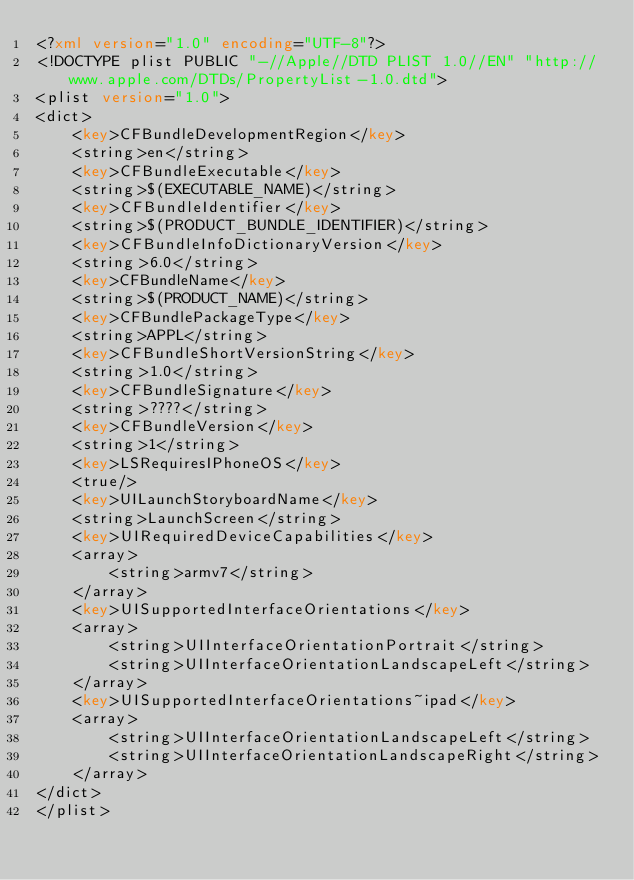<code> <loc_0><loc_0><loc_500><loc_500><_XML_><?xml version="1.0" encoding="UTF-8"?>
<!DOCTYPE plist PUBLIC "-//Apple//DTD PLIST 1.0//EN" "http://www.apple.com/DTDs/PropertyList-1.0.dtd">
<plist version="1.0">
<dict>
	<key>CFBundleDevelopmentRegion</key>
	<string>en</string>
	<key>CFBundleExecutable</key>
	<string>$(EXECUTABLE_NAME)</string>
	<key>CFBundleIdentifier</key>
	<string>$(PRODUCT_BUNDLE_IDENTIFIER)</string>
	<key>CFBundleInfoDictionaryVersion</key>
	<string>6.0</string>
	<key>CFBundleName</key>
	<string>$(PRODUCT_NAME)</string>
	<key>CFBundlePackageType</key>
	<string>APPL</string>
	<key>CFBundleShortVersionString</key>
	<string>1.0</string>
	<key>CFBundleSignature</key>
	<string>????</string>
	<key>CFBundleVersion</key>
	<string>1</string>
	<key>LSRequiresIPhoneOS</key>
	<true/>
	<key>UILaunchStoryboardName</key>
	<string>LaunchScreen</string>
	<key>UIRequiredDeviceCapabilities</key>
	<array>
		<string>armv7</string>
	</array>
	<key>UISupportedInterfaceOrientations</key>
	<array>
		<string>UIInterfaceOrientationPortrait</string>
		<string>UIInterfaceOrientationLandscapeLeft</string>
	</array>
	<key>UISupportedInterfaceOrientations~ipad</key>
	<array>
		<string>UIInterfaceOrientationLandscapeLeft</string>
		<string>UIInterfaceOrientationLandscapeRight</string>
	</array>
</dict>
</plist>
</code> 